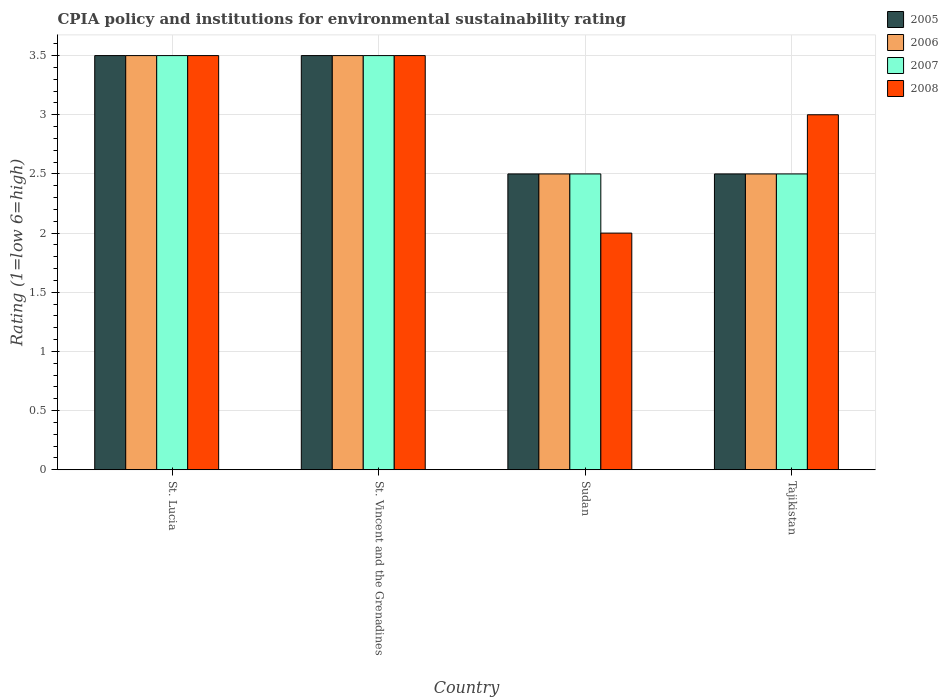How many different coloured bars are there?
Offer a very short reply. 4. How many groups of bars are there?
Provide a succinct answer. 4. Are the number of bars on each tick of the X-axis equal?
Provide a succinct answer. Yes. How many bars are there on the 2nd tick from the left?
Give a very brief answer. 4. What is the label of the 4th group of bars from the left?
Ensure brevity in your answer.  Tajikistan. What is the CPIA rating in 2008 in Tajikistan?
Keep it short and to the point. 3. Across all countries, what is the maximum CPIA rating in 2005?
Your answer should be compact. 3.5. Across all countries, what is the minimum CPIA rating in 2007?
Keep it short and to the point. 2.5. In which country was the CPIA rating in 2006 maximum?
Provide a short and direct response. St. Lucia. In which country was the CPIA rating in 2008 minimum?
Offer a very short reply. Sudan. What is the average CPIA rating in 2008 per country?
Provide a short and direct response. 3. What is the difference between the CPIA rating of/in 2008 and CPIA rating of/in 2005 in Tajikistan?
Make the answer very short. 0.5. What is the difference between the highest and the second highest CPIA rating in 2007?
Make the answer very short. -1. What is the difference between the highest and the lowest CPIA rating in 2008?
Make the answer very short. 1.5. Is it the case that in every country, the sum of the CPIA rating in 2008 and CPIA rating in 2007 is greater than the sum of CPIA rating in 2005 and CPIA rating in 2006?
Your answer should be compact. No. What does the 1st bar from the right in St. Vincent and the Grenadines represents?
Provide a succinct answer. 2008. Is it the case that in every country, the sum of the CPIA rating in 2006 and CPIA rating in 2005 is greater than the CPIA rating in 2007?
Your answer should be compact. Yes. Are all the bars in the graph horizontal?
Your answer should be very brief. No. How many countries are there in the graph?
Keep it short and to the point. 4. Are the values on the major ticks of Y-axis written in scientific E-notation?
Keep it short and to the point. No. Where does the legend appear in the graph?
Your answer should be compact. Top right. How are the legend labels stacked?
Make the answer very short. Vertical. What is the title of the graph?
Ensure brevity in your answer.  CPIA policy and institutions for environmental sustainability rating. Does "1975" appear as one of the legend labels in the graph?
Keep it short and to the point. No. What is the Rating (1=low 6=high) in 2005 in St. Lucia?
Keep it short and to the point. 3.5. What is the Rating (1=low 6=high) in 2008 in St. Lucia?
Keep it short and to the point. 3.5. What is the Rating (1=low 6=high) in 2005 in St. Vincent and the Grenadines?
Offer a very short reply. 3.5. What is the Rating (1=low 6=high) in 2006 in St. Vincent and the Grenadines?
Keep it short and to the point. 3.5. What is the Rating (1=low 6=high) in 2007 in St. Vincent and the Grenadines?
Make the answer very short. 3.5. What is the Rating (1=low 6=high) of 2008 in St. Vincent and the Grenadines?
Your answer should be compact. 3.5. What is the Rating (1=low 6=high) in 2005 in Sudan?
Your answer should be very brief. 2.5. What is the Rating (1=low 6=high) of 2007 in Sudan?
Provide a succinct answer. 2.5. What is the Rating (1=low 6=high) of 2005 in Tajikistan?
Provide a succinct answer. 2.5. What is the Rating (1=low 6=high) of 2006 in Tajikistan?
Ensure brevity in your answer.  2.5. What is the Rating (1=low 6=high) of 2007 in Tajikistan?
Give a very brief answer. 2.5. What is the Rating (1=low 6=high) in 2008 in Tajikistan?
Offer a terse response. 3. Across all countries, what is the maximum Rating (1=low 6=high) in 2005?
Your answer should be very brief. 3.5. Across all countries, what is the maximum Rating (1=low 6=high) of 2006?
Keep it short and to the point. 3.5. Across all countries, what is the minimum Rating (1=low 6=high) of 2005?
Ensure brevity in your answer.  2.5. Across all countries, what is the minimum Rating (1=low 6=high) of 2006?
Your answer should be compact. 2.5. Across all countries, what is the minimum Rating (1=low 6=high) in 2007?
Offer a terse response. 2.5. Across all countries, what is the minimum Rating (1=low 6=high) of 2008?
Keep it short and to the point. 2. What is the total Rating (1=low 6=high) in 2006 in the graph?
Make the answer very short. 12. What is the total Rating (1=low 6=high) of 2007 in the graph?
Offer a terse response. 12. What is the difference between the Rating (1=low 6=high) in 2007 in St. Lucia and that in St. Vincent and the Grenadines?
Make the answer very short. 0. What is the difference between the Rating (1=low 6=high) of 2005 in St. Lucia and that in Sudan?
Provide a short and direct response. 1. What is the difference between the Rating (1=low 6=high) of 2007 in St. Lucia and that in Sudan?
Keep it short and to the point. 1. What is the difference between the Rating (1=low 6=high) of 2008 in St. Lucia and that in Sudan?
Your response must be concise. 1.5. What is the difference between the Rating (1=low 6=high) in 2005 in St. Lucia and that in Tajikistan?
Your answer should be very brief. 1. What is the difference between the Rating (1=low 6=high) in 2006 in St. Lucia and that in Tajikistan?
Keep it short and to the point. 1. What is the difference between the Rating (1=low 6=high) of 2007 in St. Lucia and that in Tajikistan?
Offer a terse response. 1. What is the difference between the Rating (1=low 6=high) of 2005 in St. Vincent and the Grenadines and that in Sudan?
Give a very brief answer. 1. What is the difference between the Rating (1=low 6=high) of 2007 in St. Vincent and the Grenadines and that in Sudan?
Give a very brief answer. 1. What is the difference between the Rating (1=low 6=high) of 2008 in St. Vincent and the Grenadines and that in Sudan?
Provide a short and direct response. 1.5. What is the difference between the Rating (1=low 6=high) in 2005 in St. Vincent and the Grenadines and that in Tajikistan?
Make the answer very short. 1. What is the difference between the Rating (1=low 6=high) of 2007 in Sudan and that in Tajikistan?
Offer a terse response. 0. What is the difference between the Rating (1=low 6=high) in 2005 in St. Lucia and the Rating (1=low 6=high) in 2006 in St. Vincent and the Grenadines?
Provide a short and direct response. 0. What is the difference between the Rating (1=low 6=high) in 2006 in St. Lucia and the Rating (1=low 6=high) in 2007 in St. Vincent and the Grenadines?
Your answer should be very brief. 0. What is the difference between the Rating (1=low 6=high) of 2005 in St. Lucia and the Rating (1=low 6=high) of 2008 in Sudan?
Provide a succinct answer. 1.5. What is the difference between the Rating (1=low 6=high) of 2006 in St. Lucia and the Rating (1=low 6=high) of 2007 in Sudan?
Ensure brevity in your answer.  1. What is the difference between the Rating (1=low 6=high) of 2006 in St. Lucia and the Rating (1=low 6=high) of 2008 in Sudan?
Your response must be concise. 1.5. What is the difference between the Rating (1=low 6=high) of 2005 in St. Lucia and the Rating (1=low 6=high) of 2006 in Tajikistan?
Your response must be concise. 1. What is the difference between the Rating (1=low 6=high) of 2005 in St. Lucia and the Rating (1=low 6=high) of 2007 in Tajikistan?
Keep it short and to the point. 1. What is the difference between the Rating (1=low 6=high) in 2005 in St. Lucia and the Rating (1=low 6=high) in 2008 in Tajikistan?
Your response must be concise. 0.5. What is the difference between the Rating (1=low 6=high) of 2006 in St. Lucia and the Rating (1=low 6=high) of 2008 in Tajikistan?
Ensure brevity in your answer.  0.5. What is the difference between the Rating (1=low 6=high) of 2007 in St. Lucia and the Rating (1=low 6=high) of 2008 in Tajikistan?
Provide a succinct answer. 0.5. What is the difference between the Rating (1=low 6=high) of 2005 in St. Vincent and the Grenadines and the Rating (1=low 6=high) of 2006 in Sudan?
Keep it short and to the point. 1. What is the difference between the Rating (1=low 6=high) of 2005 in St. Vincent and the Grenadines and the Rating (1=low 6=high) of 2007 in Sudan?
Give a very brief answer. 1. What is the difference between the Rating (1=low 6=high) of 2005 in St. Vincent and the Grenadines and the Rating (1=low 6=high) of 2006 in Tajikistan?
Provide a short and direct response. 1. What is the difference between the Rating (1=low 6=high) in 2005 in St. Vincent and the Grenadines and the Rating (1=low 6=high) in 2007 in Tajikistan?
Keep it short and to the point. 1. What is the difference between the Rating (1=low 6=high) of 2005 in St. Vincent and the Grenadines and the Rating (1=low 6=high) of 2008 in Tajikistan?
Make the answer very short. 0.5. What is the difference between the Rating (1=low 6=high) of 2006 in St. Vincent and the Grenadines and the Rating (1=low 6=high) of 2008 in Tajikistan?
Your answer should be very brief. 0.5. What is the difference between the Rating (1=low 6=high) in 2007 in St. Vincent and the Grenadines and the Rating (1=low 6=high) in 2008 in Tajikistan?
Make the answer very short. 0.5. What is the difference between the Rating (1=low 6=high) in 2005 in Sudan and the Rating (1=low 6=high) in 2006 in Tajikistan?
Ensure brevity in your answer.  0. What is the difference between the Rating (1=low 6=high) in 2006 in Sudan and the Rating (1=low 6=high) in 2007 in Tajikistan?
Keep it short and to the point. 0. What is the difference between the Rating (1=low 6=high) of 2006 in Sudan and the Rating (1=low 6=high) of 2008 in Tajikistan?
Offer a very short reply. -0.5. What is the difference between the Rating (1=low 6=high) of 2006 and Rating (1=low 6=high) of 2007 in St. Lucia?
Offer a terse response. 0. What is the difference between the Rating (1=low 6=high) in 2005 and Rating (1=low 6=high) in 2006 in St. Vincent and the Grenadines?
Provide a short and direct response. 0. What is the difference between the Rating (1=low 6=high) of 2006 and Rating (1=low 6=high) of 2008 in St. Vincent and the Grenadines?
Give a very brief answer. 0. What is the difference between the Rating (1=low 6=high) in 2005 and Rating (1=low 6=high) in 2006 in Sudan?
Provide a succinct answer. 0. What is the difference between the Rating (1=low 6=high) in 2005 and Rating (1=low 6=high) in 2008 in Sudan?
Offer a very short reply. 0.5. What is the difference between the Rating (1=low 6=high) of 2006 and Rating (1=low 6=high) of 2007 in Sudan?
Provide a succinct answer. 0. What is the difference between the Rating (1=low 6=high) in 2005 and Rating (1=low 6=high) in 2008 in Tajikistan?
Provide a short and direct response. -0.5. What is the ratio of the Rating (1=low 6=high) of 2007 in St. Lucia to that in St. Vincent and the Grenadines?
Your answer should be compact. 1. What is the ratio of the Rating (1=low 6=high) in 2008 in St. Lucia to that in St. Vincent and the Grenadines?
Offer a terse response. 1. What is the ratio of the Rating (1=low 6=high) in 2005 in St. Lucia to that in Sudan?
Your response must be concise. 1.4. What is the ratio of the Rating (1=low 6=high) of 2008 in St. Lucia to that in Sudan?
Give a very brief answer. 1.75. What is the ratio of the Rating (1=low 6=high) in 2006 in St. Lucia to that in Tajikistan?
Offer a terse response. 1.4. What is the ratio of the Rating (1=low 6=high) of 2006 in St. Vincent and the Grenadines to that in Sudan?
Give a very brief answer. 1.4. What is the ratio of the Rating (1=low 6=high) in 2007 in St. Vincent and the Grenadines to that in Tajikistan?
Provide a succinct answer. 1.4. What is the ratio of the Rating (1=low 6=high) in 2007 in Sudan to that in Tajikistan?
Keep it short and to the point. 1. What is the ratio of the Rating (1=low 6=high) of 2008 in Sudan to that in Tajikistan?
Make the answer very short. 0.67. What is the difference between the highest and the second highest Rating (1=low 6=high) of 2005?
Provide a succinct answer. 0. What is the difference between the highest and the second highest Rating (1=low 6=high) in 2008?
Give a very brief answer. 0. What is the difference between the highest and the lowest Rating (1=low 6=high) of 2005?
Ensure brevity in your answer.  1. What is the difference between the highest and the lowest Rating (1=low 6=high) of 2006?
Provide a succinct answer. 1. What is the difference between the highest and the lowest Rating (1=low 6=high) in 2007?
Offer a terse response. 1. What is the difference between the highest and the lowest Rating (1=low 6=high) in 2008?
Give a very brief answer. 1.5. 